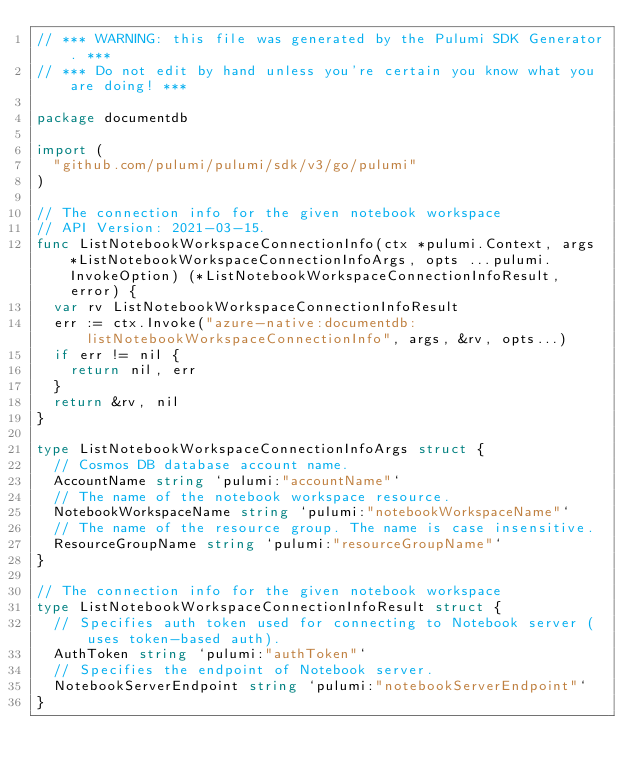Convert code to text. <code><loc_0><loc_0><loc_500><loc_500><_Go_>// *** WARNING: this file was generated by the Pulumi SDK Generator. ***
// *** Do not edit by hand unless you're certain you know what you are doing! ***

package documentdb

import (
	"github.com/pulumi/pulumi/sdk/v3/go/pulumi"
)

// The connection info for the given notebook workspace
// API Version: 2021-03-15.
func ListNotebookWorkspaceConnectionInfo(ctx *pulumi.Context, args *ListNotebookWorkspaceConnectionInfoArgs, opts ...pulumi.InvokeOption) (*ListNotebookWorkspaceConnectionInfoResult, error) {
	var rv ListNotebookWorkspaceConnectionInfoResult
	err := ctx.Invoke("azure-native:documentdb:listNotebookWorkspaceConnectionInfo", args, &rv, opts...)
	if err != nil {
		return nil, err
	}
	return &rv, nil
}

type ListNotebookWorkspaceConnectionInfoArgs struct {
	// Cosmos DB database account name.
	AccountName string `pulumi:"accountName"`
	// The name of the notebook workspace resource.
	NotebookWorkspaceName string `pulumi:"notebookWorkspaceName"`
	// The name of the resource group. The name is case insensitive.
	ResourceGroupName string `pulumi:"resourceGroupName"`
}

// The connection info for the given notebook workspace
type ListNotebookWorkspaceConnectionInfoResult struct {
	// Specifies auth token used for connecting to Notebook server (uses token-based auth).
	AuthToken string `pulumi:"authToken"`
	// Specifies the endpoint of Notebook server.
	NotebookServerEndpoint string `pulumi:"notebookServerEndpoint"`
}
</code> 